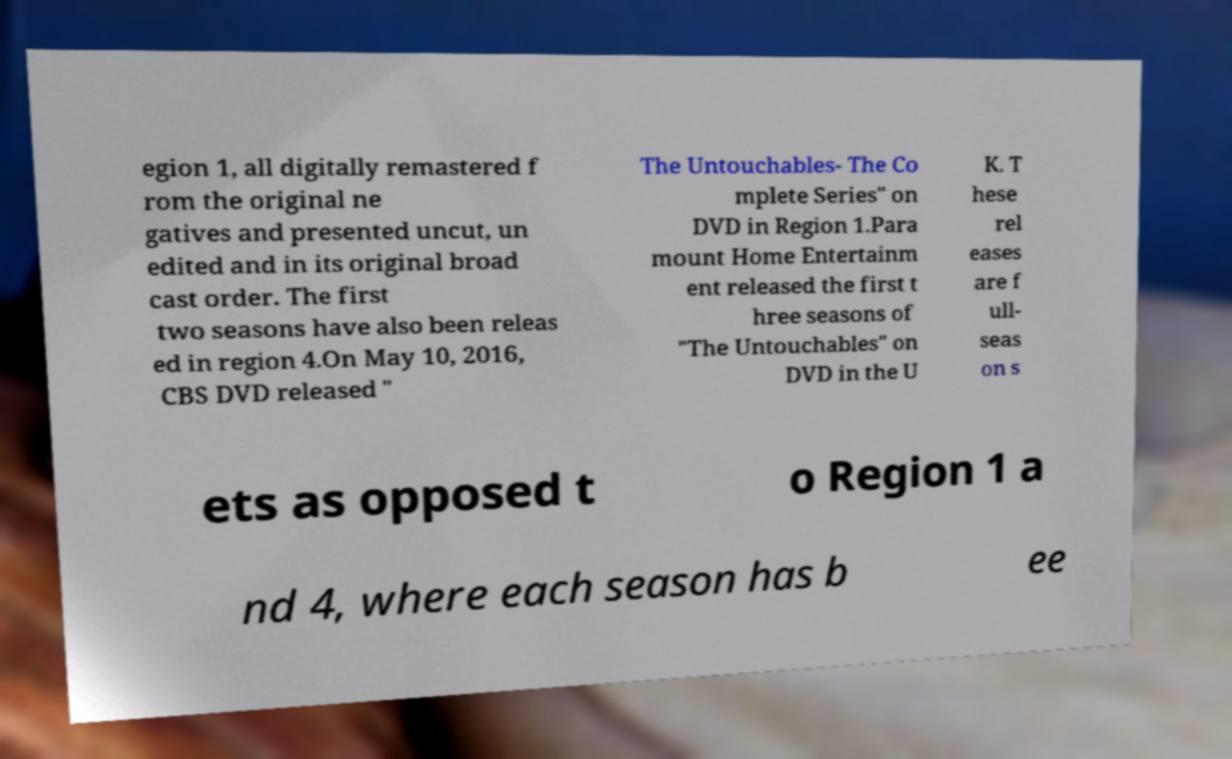Could you extract and type out the text from this image? egion 1, all digitally remastered f rom the original ne gatives and presented uncut, un edited and in its original broad cast order. The first two seasons have also been releas ed in region 4.On May 10, 2016, CBS DVD released " The Untouchables- The Co mplete Series" on DVD in Region 1.Para mount Home Entertainm ent released the first t hree seasons of "The Untouchables" on DVD in the U K. T hese rel eases are f ull- seas on s ets as opposed t o Region 1 a nd 4, where each season has b ee 